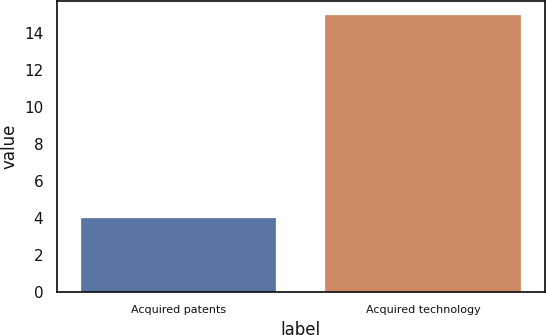Convert chart to OTSL. <chart><loc_0><loc_0><loc_500><loc_500><bar_chart><fcel>Acquired patents<fcel>Acquired technology<nl><fcel>4<fcel>15<nl></chart> 